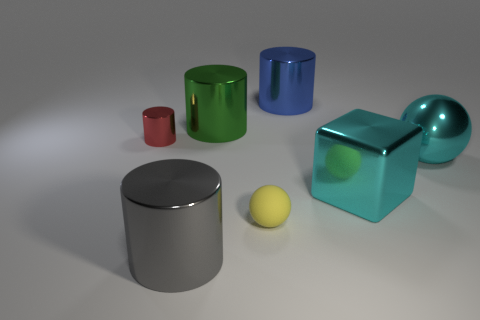How many large blue cylinders are right of the yellow object?
Offer a very short reply. 1. Is the material of the small cylinder the same as the gray cylinder left of the green metal cylinder?
Your answer should be compact. Yes. Are there any yellow matte things that have the same size as the metallic block?
Make the answer very short. No. Is the number of green metallic cylinders that are right of the large metal ball the same as the number of large cyan metal balls?
Ensure brevity in your answer.  No. What is the size of the cyan ball?
Your answer should be very brief. Large. What number of big shiny things are behind the small thing on the left side of the yellow rubber sphere?
Make the answer very short. 2. What is the shape of the metal thing that is behind the big ball and to the right of the tiny matte sphere?
Provide a short and direct response. Cylinder. What number of other blocks are the same color as the metal cube?
Provide a succinct answer. 0. There is a shiny cylinder that is in front of the metal cylinder to the left of the gray metal thing; is there a tiny shiny cylinder on the right side of it?
Provide a succinct answer. No. What size is the shiny object that is to the left of the rubber thing and to the right of the gray cylinder?
Give a very brief answer. Large. 